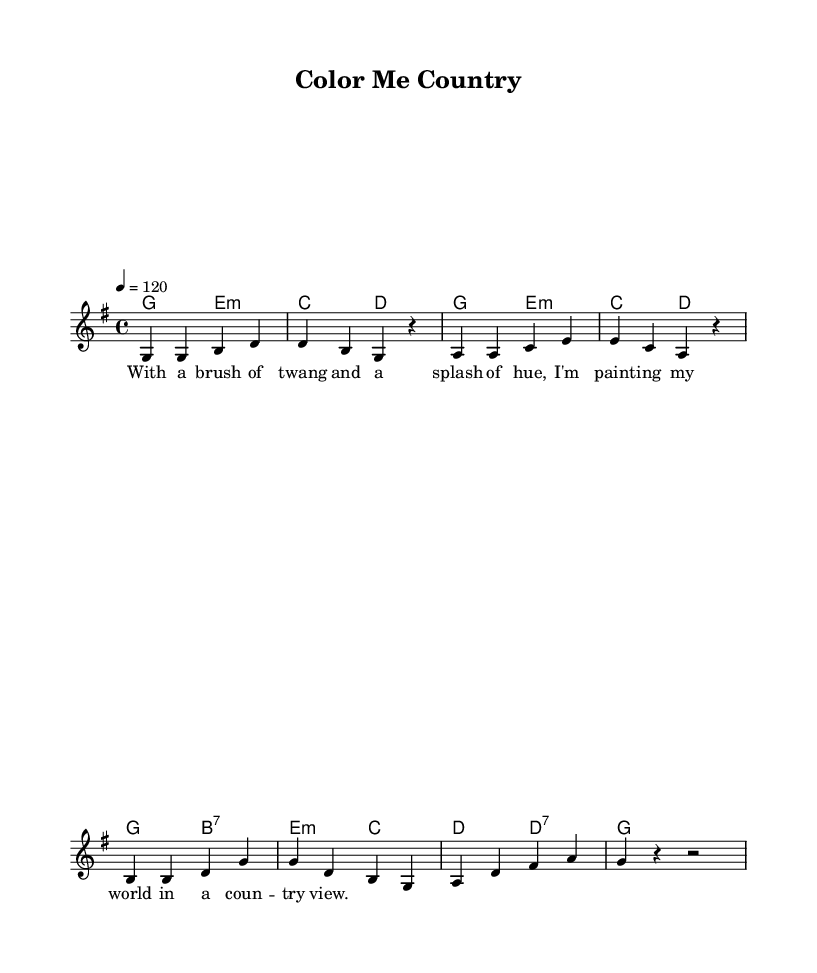What is the key signature of this music? The key signature is identified as G major, which has one sharp (F#) indicated at the beginning of the staff.
Answer: G major What is the time signature of this music? The time signature is indicated by the numbers at the beginning of the staff, which shows four beats in a measure with a quarter note receiving one beat.
Answer: 4/4 What is the tempo marking of this piece? The tempo marking specifies that the piece should be played at a speed of 120 beats per minute, denoted by the '4 = 120' instruction.
Answer: 120 How many measures are in the melody? By counting the groups of bars (each separated by a vertical line), there are a total of eight measures in the melody.
Answer: 8 What musical form does this track primarily exhibit? The structure of the song follows a verse pattern, which is common in country music, reinforcing the storytelling aspect associated with the genre.
Answer: Verse What is the predominant harmony used in this piece? By examining the chords aligned with the melody, it’s clear that G major is the primary harmony used throughout most of the song.
Answer: G major What is the theme expressed in the lyrics? The lyrics communicate the joy of creativity and personal expression through art, emphasizing a vibrant and colorful approach to life, which ties closely to visual arts themes.
Answer: Creativity 